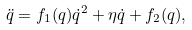Convert formula to latex. <formula><loc_0><loc_0><loc_500><loc_500>\ddot { q } = f _ { 1 } ( q ) \dot { q } ^ { 2 } + \eta \dot { q } + f _ { 2 } ( q ) ,</formula> 